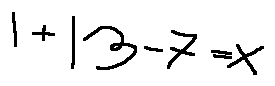<formula> <loc_0><loc_0><loc_500><loc_500>1 + 1 3 - 7 = x</formula> 